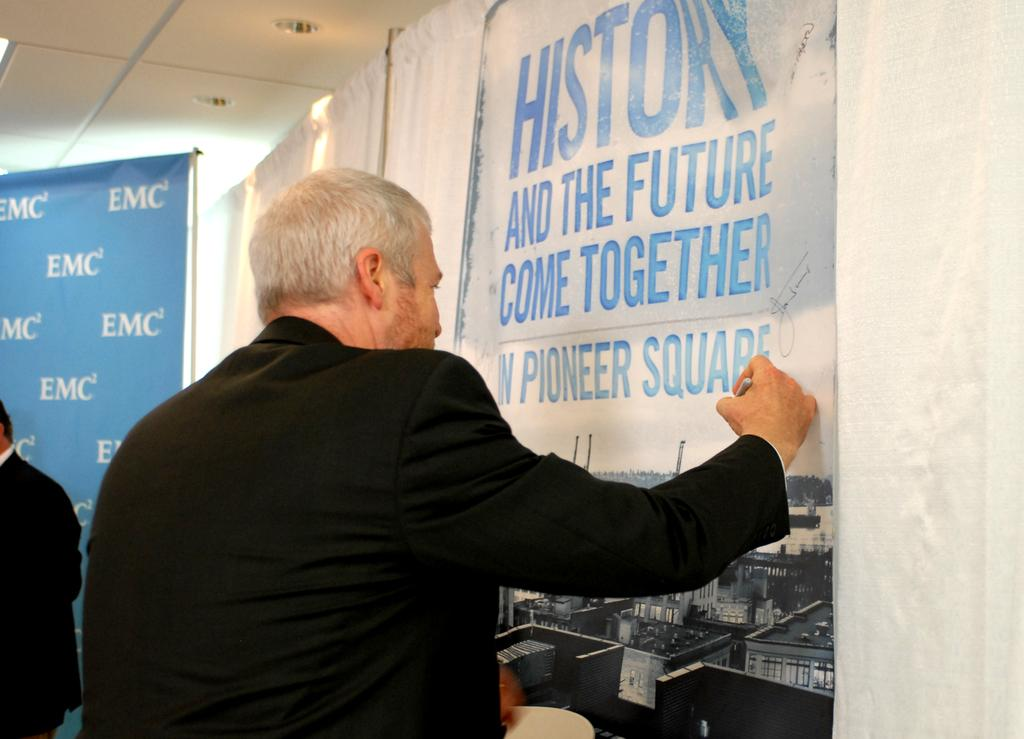<image>
Describe the image concisely. A man signs a poster advertising an event in Pioneer Square. 